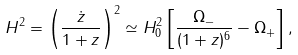Convert formula to latex. <formula><loc_0><loc_0><loc_500><loc_500>H ^ { 2 } = \left ( \frac { \dot { z } } { 1 + z } \right ) ^ { 2 } \simeq H ^ { 2 } _ { 0 } \left [ \frac { \Omega _ { - } } { ( 1 + z ) ^ { 6 } } - \Omega _ { + } \right ] ,</formula> 